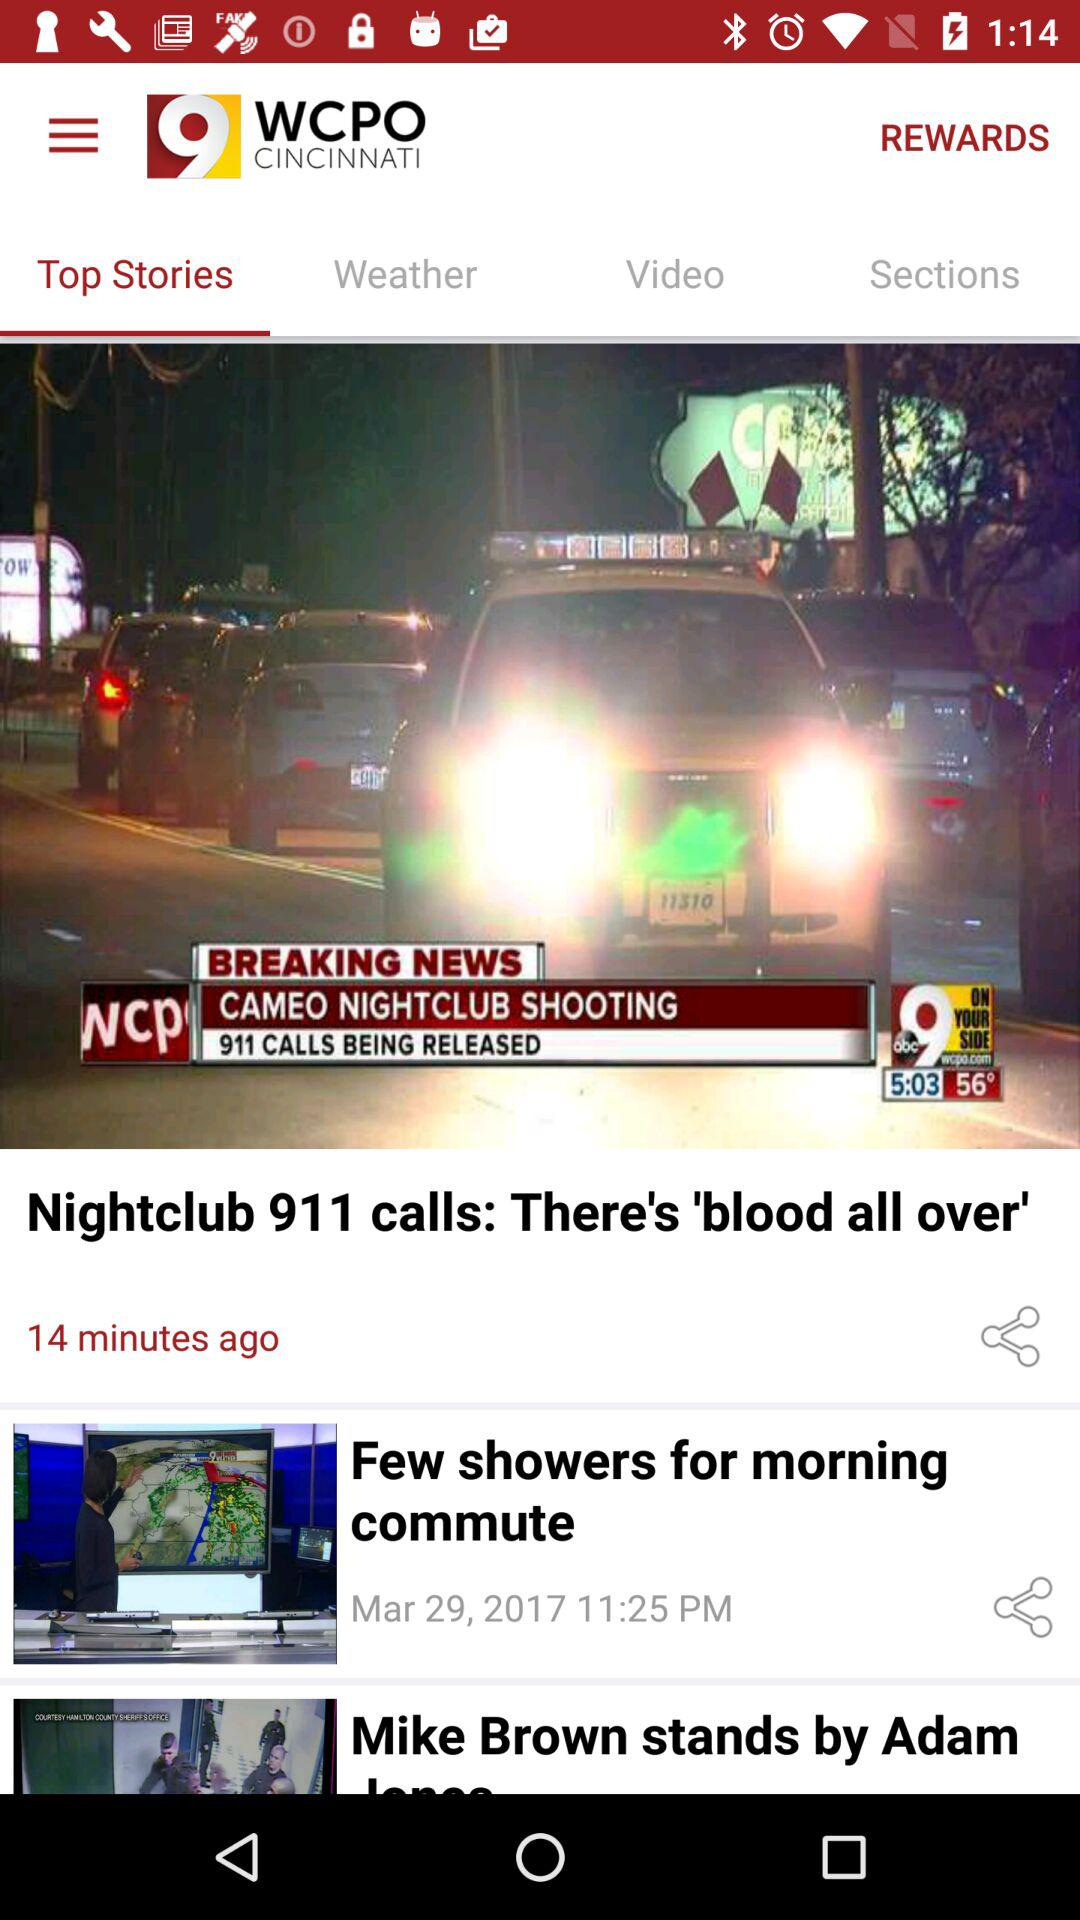Which tab am I using? You are using "Top Stories". 